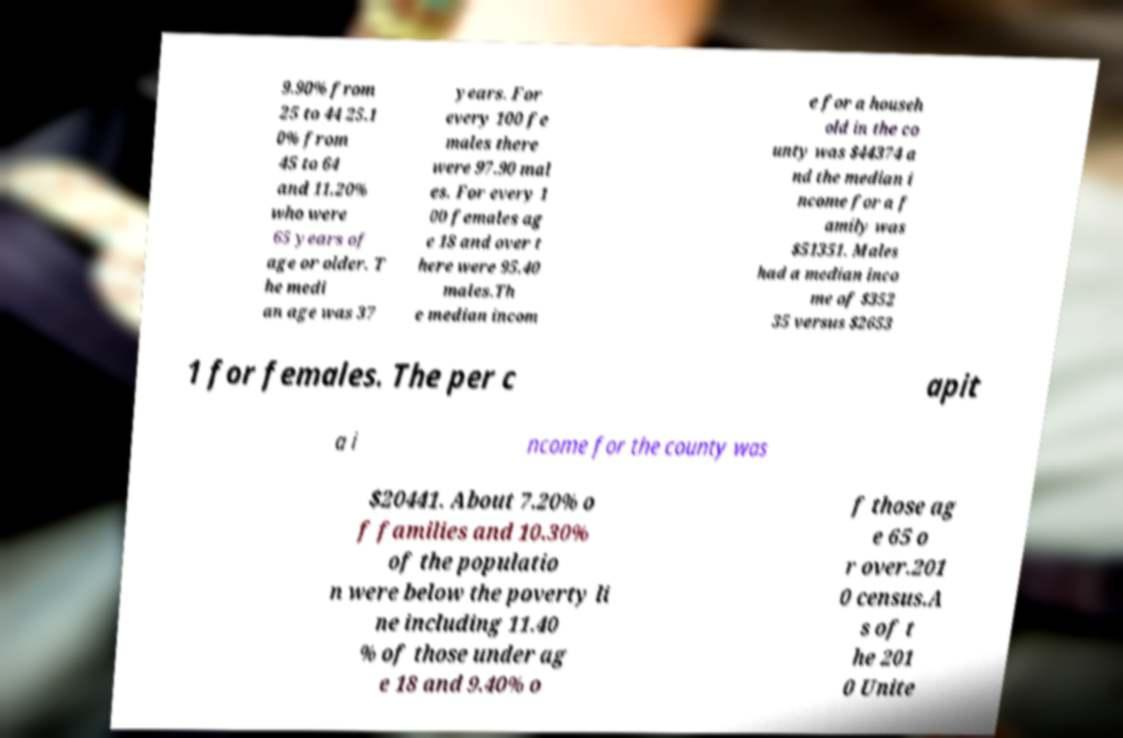Please read and relay the text visible in this image. What does it say? 9.90% from 25 to 44 25.1 0% from 45 to 64 and 11.20% who were 65 years of age or older. T he medi an age was 37 years. For every 100 fe males there were 97.90 mal es. For every 1 00 females ag e 18 and over t here were 95.40 males.Th e median incom e for a househ old in the co unty was $44374 a nd the median i ncome for a f amily was $51351. Males had a median inco me of $352 35 versus $2653 1 for females. The per c apit a i ncome for the county was $20441. About 7.20% o f families and 10.30% of the populatio n were below the poverty li ne including 11.40 % of those under ag e 18 and 9.40% o f those ag e 65 o r over.201 0 census.A s of t he 201 0 Unite 